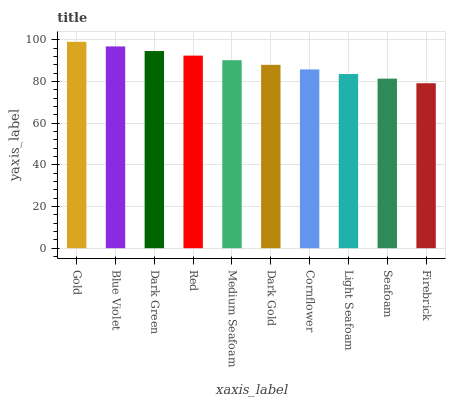Is Firebrick the minimum?
Answer yes or no. Yes. Is Gold the maximum?
Answer yes or no. Yes. Is Blue Violet the minimum?
Answer yes or no. No. Is Blue Violet the maximum?
Answer yes or no. No. Is Gold greater than Blue Violet?
Answer yes or no. Yes. Is Blue Violet less than Gold?
Answer yes or no. Yes. Is Blue Violet greater than Gold?
Answer yes or no. No. Is Gold less than Blue Violet?
Answer yes or no. No. Is Medium Seafoam the high median?
Answer yes or no. Yes. Is Dark Gold the low median?
Answer yes or no. Yes. Is Seafoam the high median?
Answer yes or no. No. Is Gold the low median?
Answer yes or no. No. 